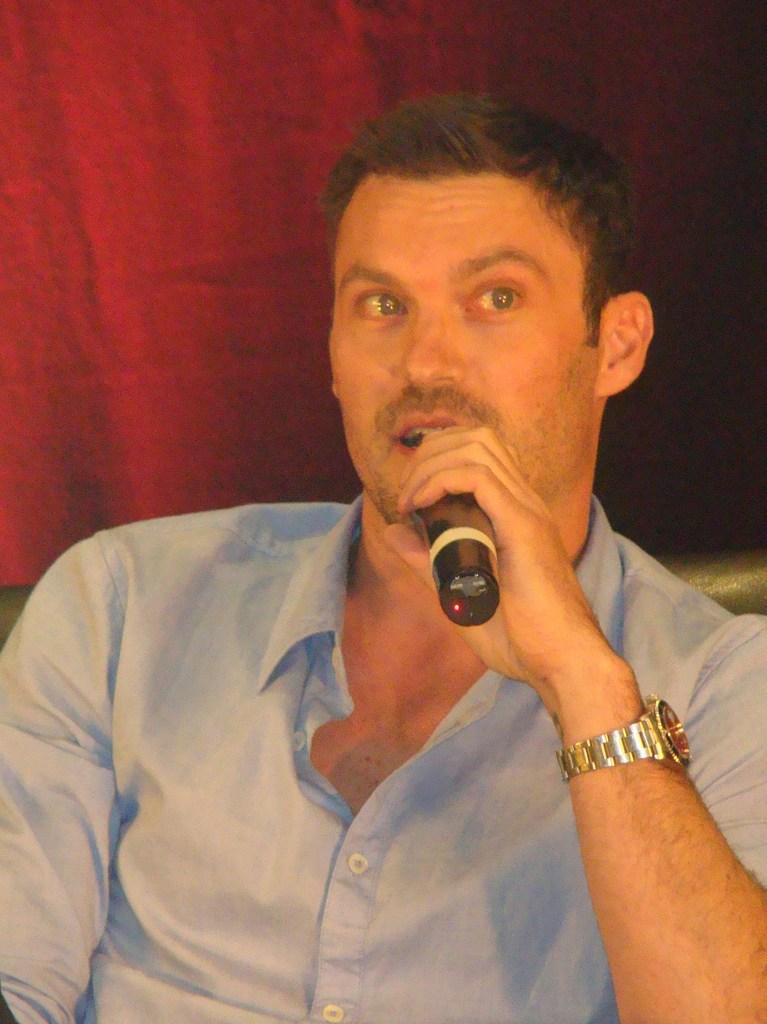What is the man in the image doing? The man is sitting in the image. What is the man holding in the image? The man is holding a black color microphone. What type of watch is the man wearing? The man is wearing a steel watch. What can be seen in the background of the image? There is a red color curtain in the background of the image. Can you see any eggs in the image? There are no eggs present in the image. Is there any grass visible in the image? There is no grass visible in the image. 